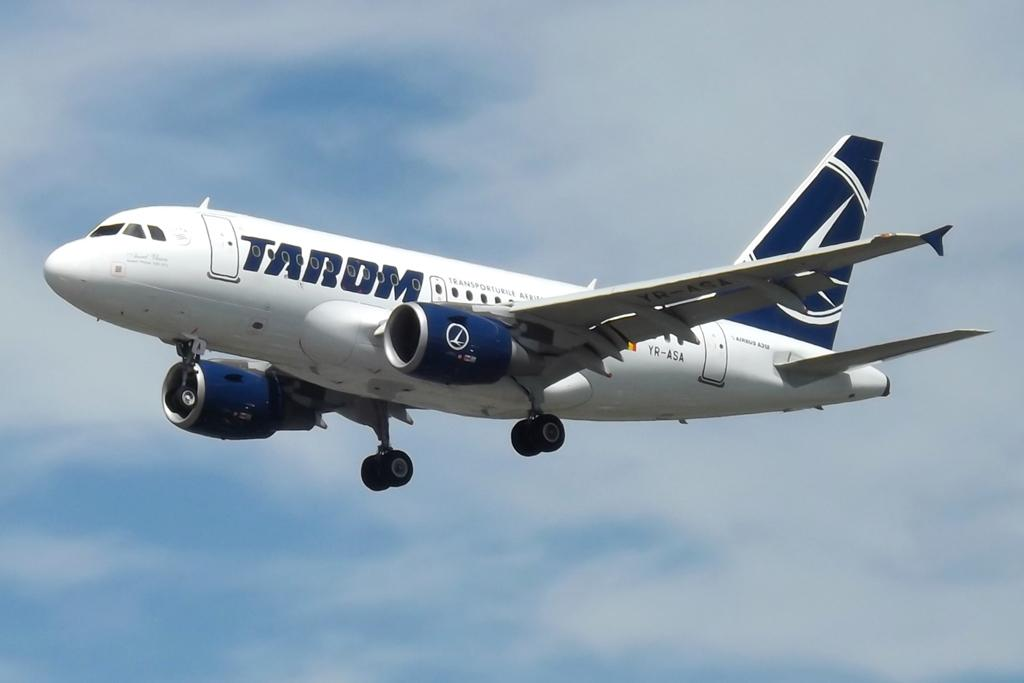<image>
Relay a brief, clear account of the picture shown. An airliner from Tarom is painted blue and white. 